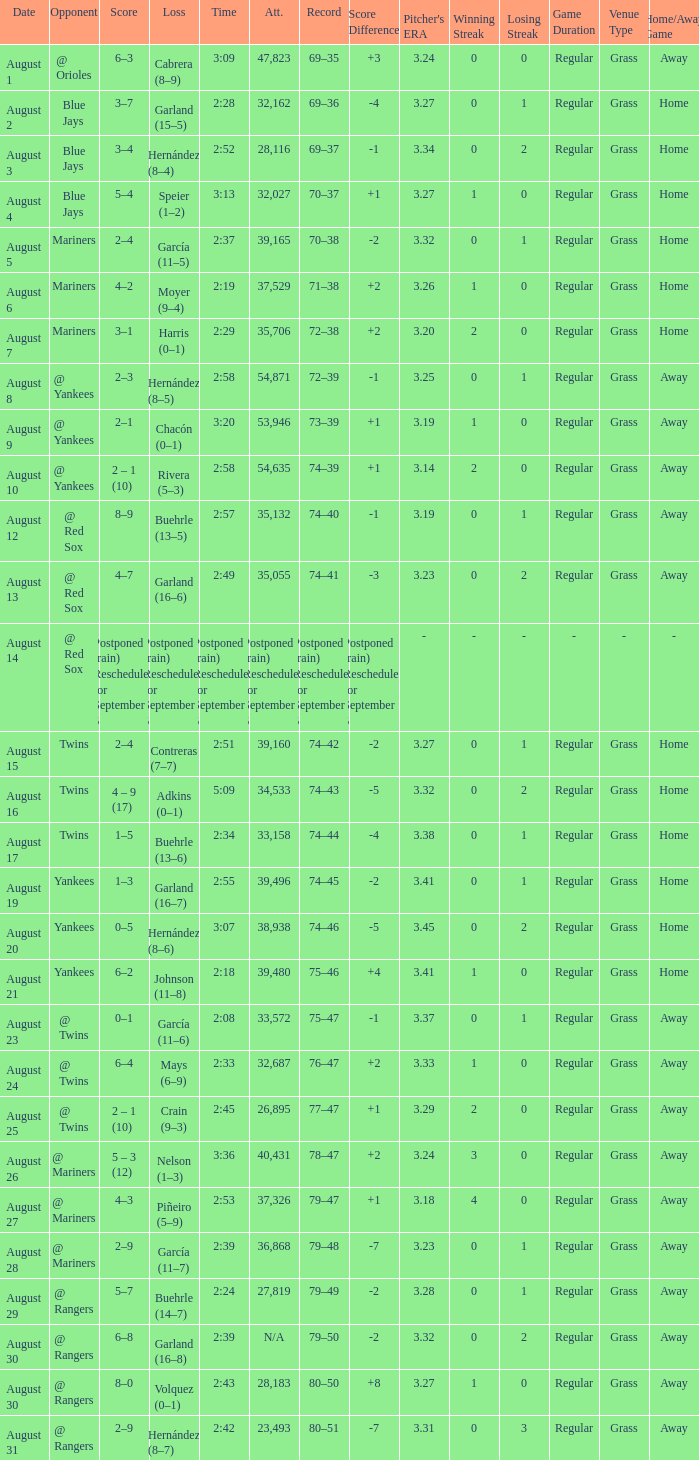Who lost on August 27? Piñeiro (5–9). 